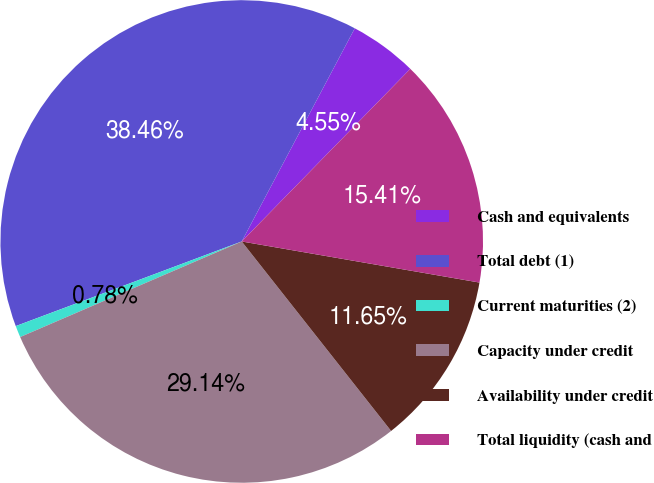<chart> <loc_0><loc_0><loc_500><loc_500><pie_chart><fcel>Cash and equivalents<fcel>Total debt (1)<fcel>Current maturities (2)<fcel>Capacity under credit<fcel>Availability under credit<fcel>Total liquidity (cash and<nl><fcel>4.55%<fcel>38.46%<fcel>0.78%<fcel>29.14%<fcel>11.65%<fcel>15.41%<nl></chart> 